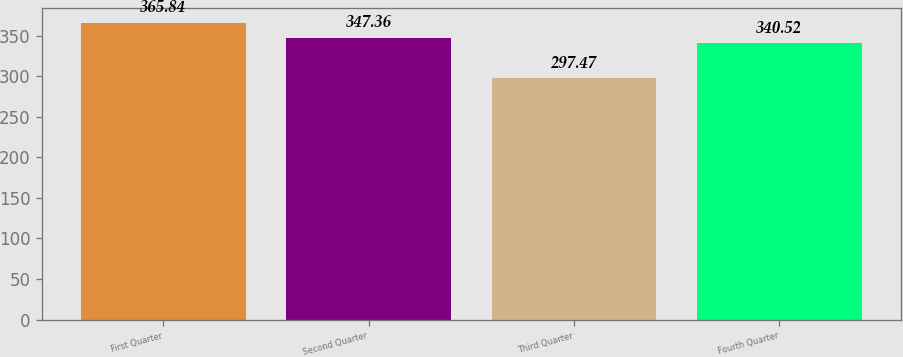<chart> <loc_0><loc_0><loc_500><loc_500><bar_chart><fcel>First Quarter<fcel>Second Quarter<fcel>Third Quarter<fcel>Fourth Quarter<nl><fcel>365.84<fcel>347.36<fcel>297.47<fcel>340.52<nl></chart> 